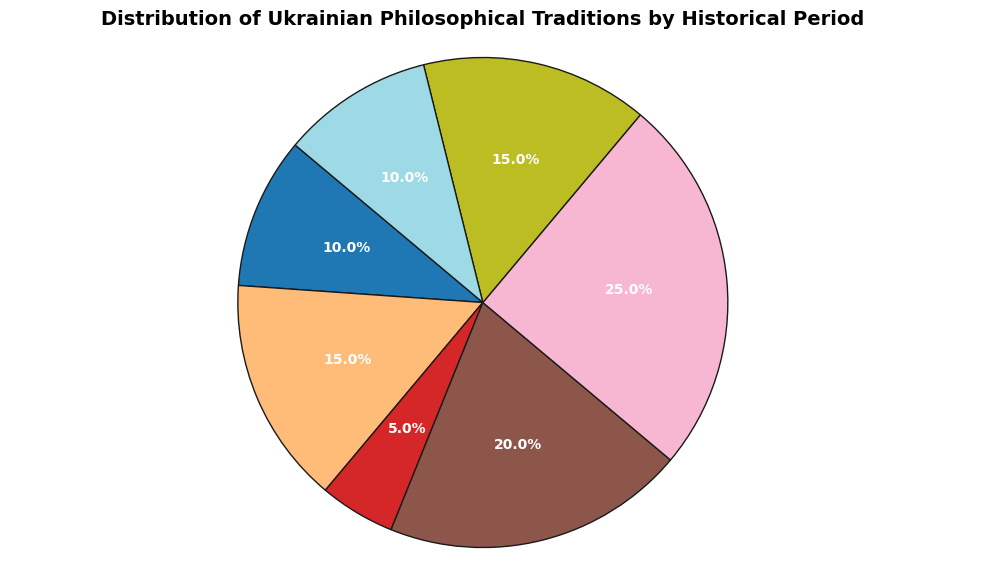What is the percentage of the Early Modern Philosophy period in the distribution? To find the percentage of the Early Modern Philosophy period, we just need to look at the corresponding slice in the pie chart and read its percentage value.
Answer: 20% Which historical period has the largest representation in the distribution? By visually inspecting the pie chart, we can identify the slice that occupies the most space.
Answer: 19th Century Philosophy Is the Medieval Philosophy period's percentage greater than or less than the Cossack Baroque period's percentage? We compare the percentages of Medieval Philosophy and Cossack Baroque from the pie chart, which are 10% and 5%, respectively.
Answer: Greater What is the total percentage of Renaissance Philosophy and Soviet Era Philosophy combined? We add the percentage values of Renaissance Philosophy (15%) and Soviet Era Philosophy (15%) as shown in the pie chart. Thus, \(15\% + 15\% = 30\%\).
Answer: 30% Which periods have equal representation in the distribution? By inspecting the chart, we identify that both Renaissance Philosophy and Soviet Era Philosophy each have a 15% share.
Answer: Renaissance Philosophy and Soviet Era Philosophy What is the combined percentage of all periods not exceeding 20% individually? We sum percentages of all slices with values ≤ 20%. This includes Medieval Philosophy (10%), Renaissance Philosophy (15%), Cossack Baroque (5%), Early Modern Philosophy (20%), and Contemporary Philosophy (10%). \(10\% + 15\% + 5\% + 20\% + 10\% = 60\%\).
Answer: 60% How does the percentage of Contemporary Philosophy compare to that of Medieval Philosophy? We compare the percentages of Contemporary Philosophy and Medieval Philosophy as represented in the pie chart. Both are 10%.
Answer: Equal If you combine the percentages of the Cossack Baroque, Contemporary Philosophy, and Medieval Philosophy periods, what is the total? By summing up the percentages of Cossack Baroque (5%), Contemporary Philosophy (10%), and Medieval Philosophy (10%), we get \(5\% + 10\% + 10\% = 25\%\).
Answer: 25% Based on the pie chart, is the percentage of 19th Century Philosophy more than double the percentage of Cossack Baroque? Double the Cossack Baroque's percentage (5%) is \(5\% \times 2 = 10%\). The percentage of 19th Century Philosophy is 25%, which is more than 10%.
Answer: Yes Visually, which color appears to represent the largest section of the pie chart? By inspecting the chart visually, we look for the most expansive section and its corresponding color.
Answer: Color of the 19th Century Philosophy slice 